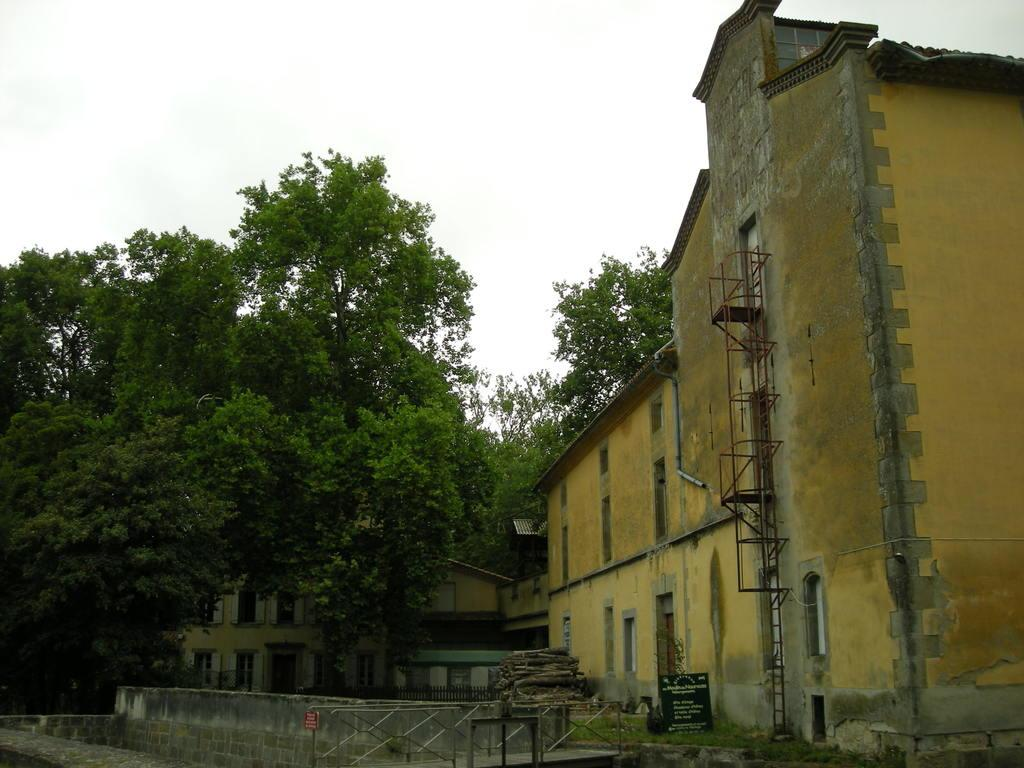What type of structures can be seen in the image? There are buildings in the image. What architectural features are visible on the buildings? Windows are visible in the image. What type of vegetation is present in the image? Trees are present in the image. What material is used for the sticks visible in the image? Wood sticks are visible in the image. What type of barrier can be seen in the image? There is a fence in the image. What type of signage is present in the image? There is a board with text in the image. What type of barrier is present on the side of the buildings? There is a wall in the image. What is visible in the background of the image? The sky is visible in the background of the image. How many cats are sitting on the veil in the image? There is no veil or cats present in the image. What type of oil is being used to paint the buildings in the image? There is no indication of painting or oil being used in the image. 